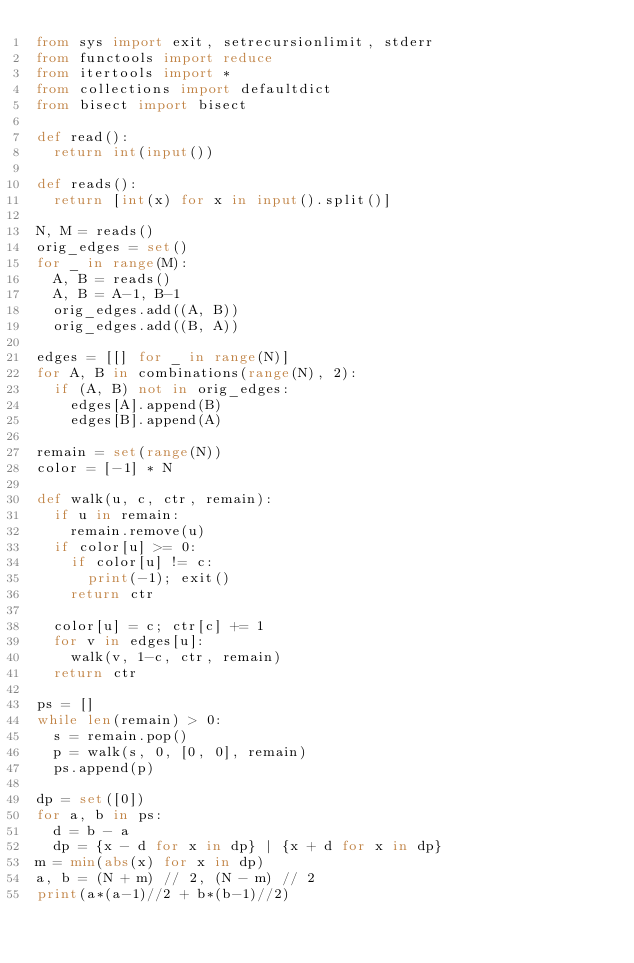Convert code to text. <code><loc_0><loc_0><loc_500><loc_500><_Python_>from sys import exit, setrecursionlimit, stderr
from functools import reduce
from itertools import *
from collections import defaultdict
from bisect import bisect
 
def read():
  return int(input())
 
def reads():
  return [int(x) for x in input().split()]

N, M = reads()
orig_edges = set()
for _ in range(M):
  A, B = reads()
  A, B = A-1, B-1
  orig_edges.add((A, B))
  orig_edges.add((B, A))

edges = [[] for _ in range(N)]
for A, B in combinations(range(N), 2):
  if (A, B) not in orig_edges:
    edges[A].append(B)
    edges[B].append(A)

remain = set(range(N))
color = [-1] * N

def walk(u, c, ctr, remain):
  if u in remain:
    remain.remove(u)
  if color[u] >= 0:
    if color[u] != c:
      print(-1); exit()
    return ctr

  color[u] = c; ctr[c] += 1
  for v in edges[u]:
    walk(v, 1-c, ctr, remain)
  return ctr

ps = []
while len(remain) > 0:
  s = remain.pop()
  p = walk(s, 0, [0, 0], remain)
  ps.append(p)

dp = set([0])
for a, b in ps:
  d = b - a
  dp = {x - d for x in dp} | {x + d for x in dp}
m = min(abs(x) for x in dp)
a, b = (N + m) // 2, (N - m) // 2
print(a*(a-1)//2 + b*(b-1)//2)
</code> 